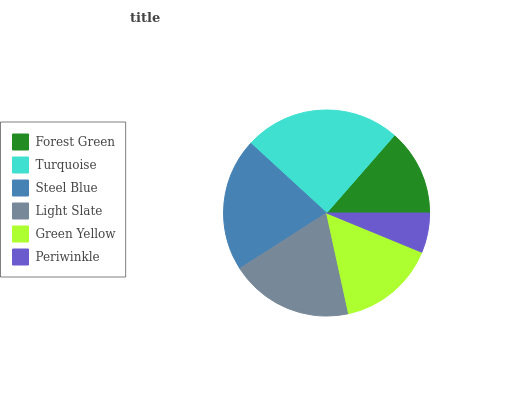Is Periwinkle the minimum?
Answer yes or no. Yes. Is Turquoise the maximum?
Answer yes or no. Yes. Is Steel Blue the minimum?
Answer yes or no. No. Is Steel Blue the maximum?
Answer yes or no. No. Is Turquoise greater than Steel Blue?
Answer yes or no. Yes. Is Steel Blue less than Turquoise?
Answer yes or no. Yes. Is Steel Blue greater than Turquoise?
Answer yes or no. No. Is Turquoise less than Steel Blue?
Answer yes or no. No. Is Light Slate the high median?
Answer yes or no. Yes. Is Green Yellow the low median?
Answer yes or no. Yes. Is Periwinkle the high median?
Answer yes or no. No. Is Steel Blue the low median?
Answer yes or no. No. 